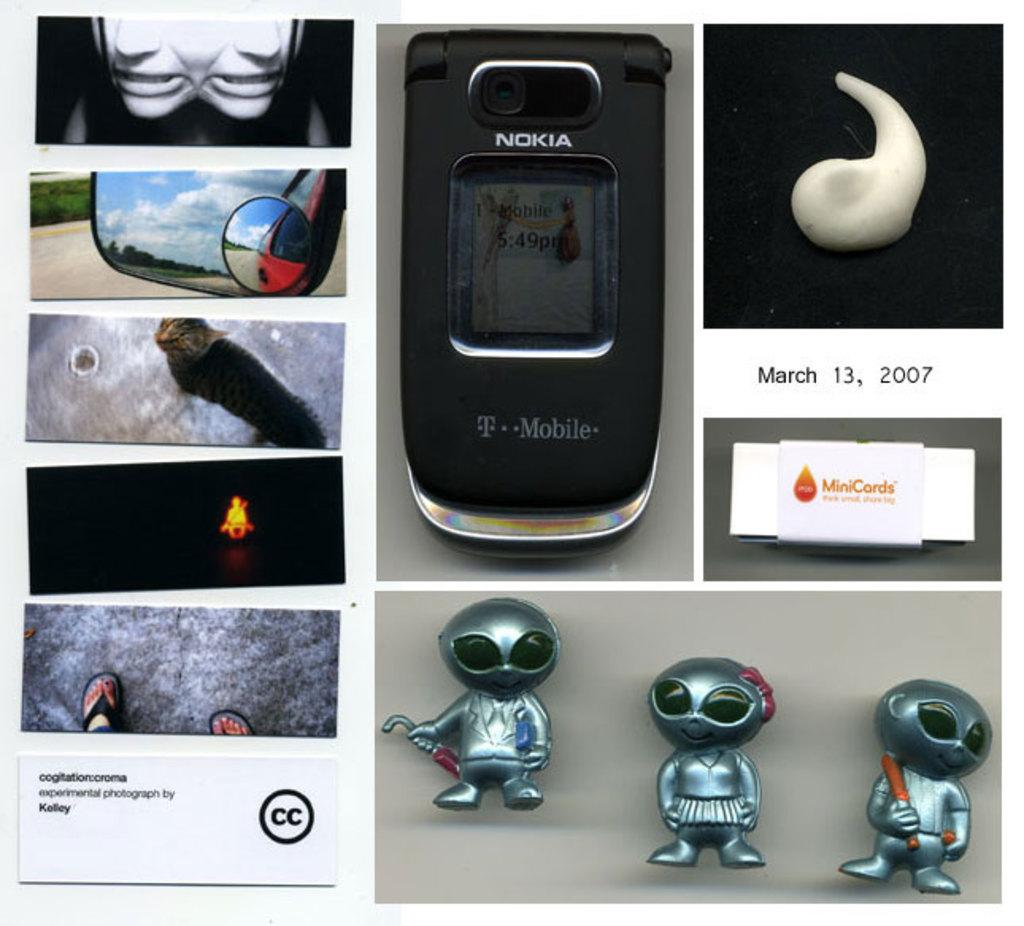<image>
Give a short and clear explanation of the subsequent image. Various images including a Nokia phone, some little silver alien figurines and a rear view mirror. 